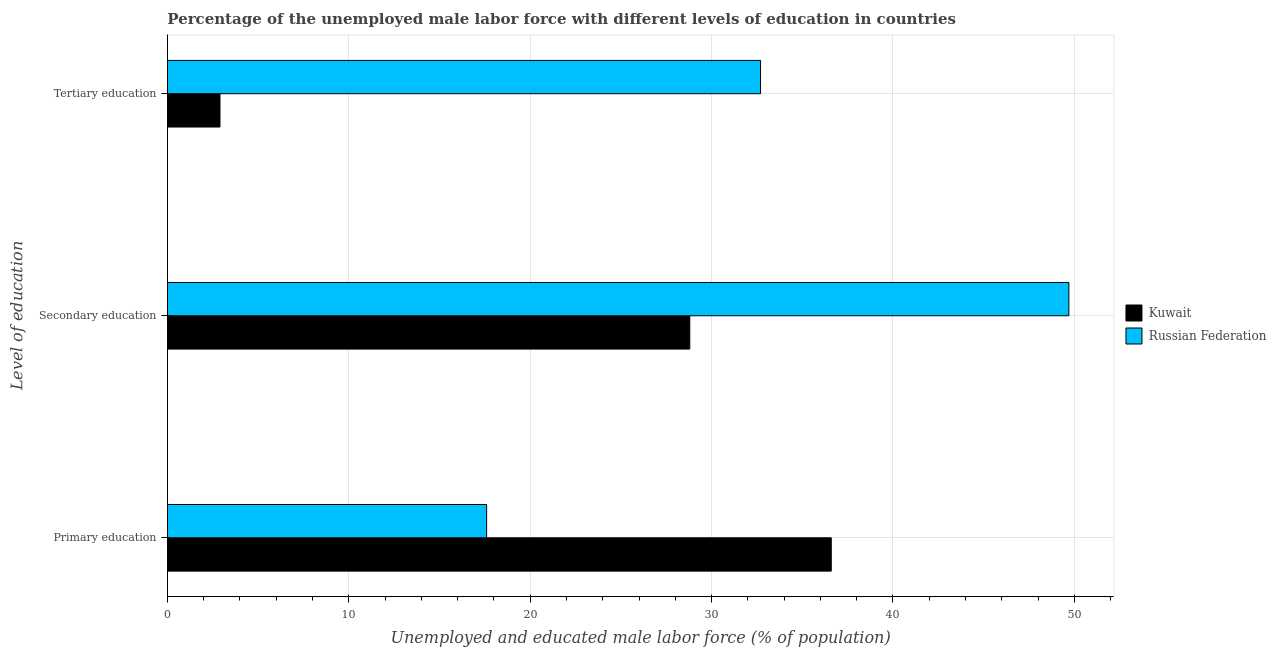How many different coloured bars are there?
Make the answer very short. 2. Are the number of bars per tick equal to the number of legend labels?
Keep it short and to the point. Yes. Are the number of bars on each tick of the Y-axis equal?
Offer a very short reply. Yes. How many bars are there on the 1st tick from the bottom?
Your answer should be compact. 2. What is the label of the 3rd group of bars from the top?
Your response must be concise. Primary education. What is the percentage of male labor force who received secondary education in Russian Federation?
Your answer should be compact. 49.7. Across all countries, what is the maximum percentage of male labor force who received primary education?
Offer a very short reply. 36.6. Across all countries, what is the minimum percentage of male labor force who received tertiary education?
Ensure brevity in your answer.  2.9. In which country was the percentage of male labor force who received tertiary education maximum?
Offer a terse response. Russian Federation. In which country was the percentage of male labor force who received secondary education minimum?
Keep it short and to the point. Kuwait. What is the total percentage of male labor force who received primary education in the graph?
Offer a terse response. 54.2. What is the difference between the percentage of male labor force who received tertiary education in Kuwait and that in Russian Federation?
Provide a short and direct response. -29.8. What is the difference between the percentage of male labor force who received secondary education in Russian Federation and the percentage of male labor force who received primary education in Kuwait?
Ensure brevity in your answer.  13.1. What is the average percentage of male labor force who received primary education per country?
Ensure brevity in your answer.  27.1. What is the difference between the percentage of male labor force who received primary education and percentage of male labor force who received tertiary education in Kuwait?
Give a very brief answer. 33.7. In how many countries, is the percentage of male labor force who received tertiary education greater than 42 %?
Your answer should be very brief. 0. What is the ratio of the percentage of male labor force who received secondary education in Russian Federation to that in Kuwait?
Your answer should be compact. 1.73. Is the percentage of male labor force who received primary education in Kuwait less than that in Russian Federation?
Make the answer very short. No. What is the difference between the highest and the second highest percentage of male labor force who received primary education?
Keep it short and to the point. 19. What is the difference between the highest and the lowest percentage of male labor force who received tertiary education?
Provide a short and direct response. 29.8. Is the sum of the percentage of male labor force who received tertiary education in Russian Federation and Kuwait greater than the maximum percentage of male labor force who received primary education across all countries?
Provide a short and direct response. No. What does the 1st bar from the top in Primary education represents?
Provide a short and direct response. Russian Federation. What does the 2nd bar from the bottom in Secondary education represents?
Offer a terse response. Russian Federation. Is it the case that in every country, the sum of the percentage of male labor force who received primary education and percentage of male labor force who received secondary education is greater than the percentage of male labor force who received tertiary education?
Ensure brevity in your answer.  Yes. How many bars are there?
Offer a terse response. 6. Are all the bars in the graph horizontal?
Give a very brief answer. Yes. Are the values on the major ticks of X-axis written in scientific E-notation?
Your answer should be very brief. No. Where does the legend appear in the graph?
Your response must be concise. Center right. How many legend labels are there?
Provide a short and direct response. 2. How are the legend labels stacked?
Ensure brevity in your answer.  Vertical. What is the title of the graph?
Offer a terse response. Percentage of the unemployed male labor force with different levels of education in countries. Does "Mongolia" appear as one of the legend labels in the graph?
Offer a very short reply. No. What is the label or title of the X-axis?
Your answer should be compact. Unemployed and educated male labor force (% of population). What is the label or title of the Y-axis?
Your answer should be compact. Level of education. What is the Unemployed and educated male labor force (% of population) of Kuwait in Primary education?
Provide a succinct answer. 36.6. What is the Unemployed and educated male labor force (% of population) of Russian Federation in Primary education?
Your answer should be very brief. 17.6. What is the Unemployed and educated male labor force (% of population) of Kuwait in Secondary education?
Make the answer very short. 28.8. What is the Unemployed and educated male labor force (% of population) of Russian Federation in Secondary education?
Keep it short and to the point. 49.7. What is the Unemployed and educated male labor force (% of population) in Kuwait in Tertiary education?
Ensure brevity in your answer.  2.9. What is the Unemployed and educated male labor force (% of population) in Russian Federation in Tertiary education?
Your answer should be compact. 32.7. Across all Level of education, what is the maximum Unemployed and educated male labor force (% of population) of Kuwait?
Offer a very short reply. 36.6. Across all Level of education, what is the maximum Unemployed and educated male labor force (% of population) in Russian Federation?
Your answer should be very brief. 49.7. Across all Level of education, what is the minimum Unemployed and educated male labor force (% of population) of Kuwait?
Provide a succinct answer. 2.9. Across all Level of education, what is the minimum Unemployed and educated male labor force (% of population) of Russian Federation?
Offer a very short reply. 17.6. What is the total Unemployed and educated male labor force (% of population) of Kuwait in the graph?
Your answer should be very brief. 68.3. What is the total Unemployed and educated male labor force (% of population) of Russian Federation in the graph?
Provide a succinct answer. 100. What is the difference between the Unemployed and educated male labor force (% of population) of Russian Federation in Primary education and that in Secondary education?
Give a very brief answer. -32.1. What is the difference between the Unemployed and educated male labor force (% of population) in Kuwait in Primary education and that in Tertiary education?
Keep it short and to the point. 33.7. What is the difference between the Unemployed and educated male labor force (% of population) of Russian Federation in Primary education and that in Tertiary education?
Your answer should be very brief. -15.1. What is the difference between the Unemployed and educated male labor force (% of population) in Kuwait in Secondary education and that in Tertiary education?
Your answer should be very brief. 25.9. What is the difference between the Unemployed and educated male labor force (% of population) of Kuwait in Primary education and the Unemployed and educated male labor force (% of population) of Russian Federation in Tertiary education?
Give a very brief answer. 3.9. What is the average Unemployed and educated male labor force (% of population) in Kuwait per Level of education?
Your answer should be very brief. 22.77. What is the average Unemployed and educated male labor force (% of population) of Russian Federation per Level of education?
Ensure brevity in your answer.  33.33. What is the difference between the Unemployed and educated male labor force (% of population) of Kuwait and Unemployed and educated male labor force (% of population) of Russian Federation in Secondary education?
Your answer should be compact. -20.9. What is the difference between the Unemployed and educated male labor force (% of population) in Kuwait and Unemployed and educated male labor force (% of population) in Russian Federation in Tertiary education?
Provide a short and direct response. -29.8. What is the ratio of the Unemployed and educated male labor force (% of population) of Kuwait in Primary education to that in Secondary education?
Your answer should be very brief. 1.27. What is the ratio of the Unemployed and educated male labor force (% of population) of Russian Federation in Primary education to that in Secondary education?
Your response must be concise. 0.35. What is the ratio of the Unemployed and educated male labor force (% of population) in Kuwait in Primary education to that in Tertiary education?
Keep it short and to the point. 12.62. What is the ratio of the Unemployed and educated male labor force (% of population) in Russian Federation in Primary education to that in Tertiary education?
Your answer should be very brief. 0.54. What is the ratio of the Unemployed and educated male labor force (% of population) of Kuwait in Secondary education to that in Tertiary education?
Provide a short and direct response. 9.93. What is the ratio of the Unemployed and educated male labor force (% of population) in Russian Federation in Secondary education to that in Tertiary education?
Provide a short and direct response. 1.52. What is the difference between the highest and the second highest Unemployed and educated male labor force (% of population) of Kuwait?
Your answer should be compact. 7.8. What is the difference between the highest and the second highest Unemployed and educated male labor force (% of population) of Russian Federation?
Give a very brief answer. 17. What is the difference between the highest and the lowest Unemployed and educated male labor force (% of population) in Kuwait?
Your answer should be very brief. 33.7. What is the difference between the highest and the lowest Unemployed and educated male labor force (% of population) in Russian Federation?
Offer a terse response. 32.1. 